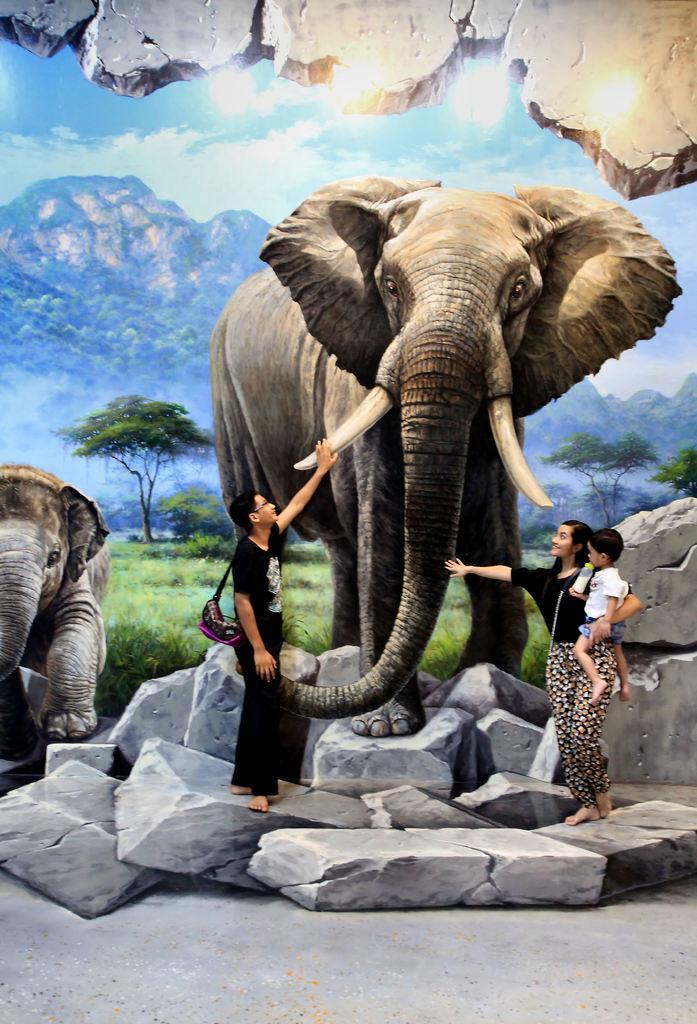Describe this image in one or two sentences. In this picture, the sky is blue and cloudy. There is a mountain and a tree. There is some grass. To the left side,elephant is there. In the middle there is another elephant , a man wearing a bag is holding the tusk of an elephant. To the right side,there is a woman who is holding the trunk of an elephant and she is catching a boy who is holding a bottle. 